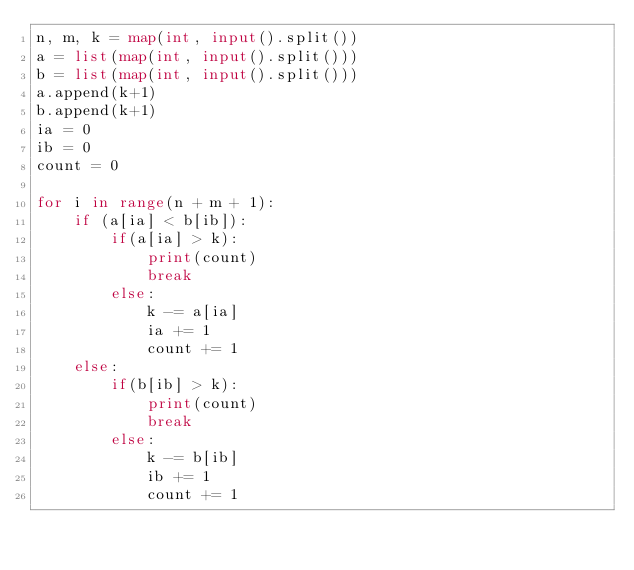<code> <loc_0><loc_0><loc_500><loc_500><_Python_>n, m, k = map(int, input().split())
a = list(map(int, input().split()))
b = list(map(int, input().split()))
a.append(k+1)
b.append(k+1)
ia = 0
ib = 0
count = 0
 
for i in range(n + m + 1):
    if (a[ia] < b[ib]):
        if(a[ia] > k):
            print(count)
            break
        else:
            k -= a[ia]
            ia += 1
            count += 1
    else:
        if(b[ib] > k):
            print(count)
            break
        else:
            k -= b[ib]
            ib += 1
            count += 1</code> 